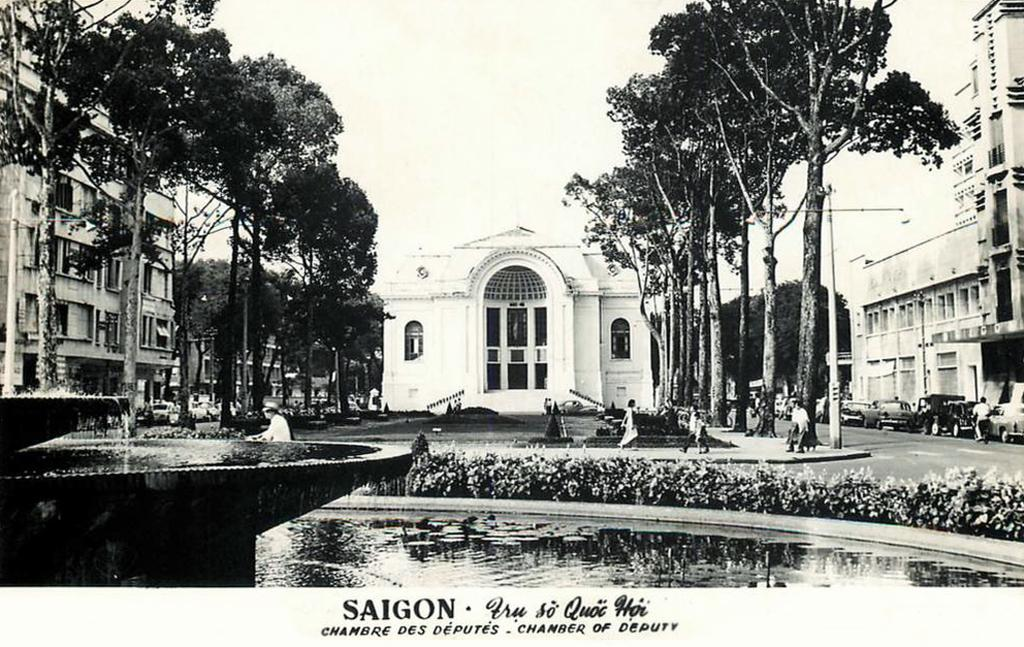What type of structures can be seen in the image? There are buildings in the image. What architectural features can be observed on the buildings? Windows are visible in the image. What natural elements are present in the image? There are trees and water visible in the image. What type of water feature is present in the image? There is a fountain in the image. Who or what is visible in the image? There are people and vehicles on the road in the image. What can be seen in the sky in the image? The sky is visible in the image. What advertisement can be seen on the side of the building in the image? There is no advertisement visible on the buildings in the image. What type of engine is powering the fountain in the image? The image does not provide information about the fountain's engine, as fountains typically do not have engines. 